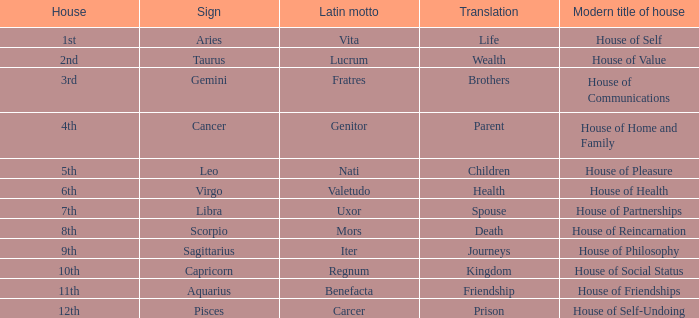What is the Latin motto of the sign that translates to spouse? Uxor. 